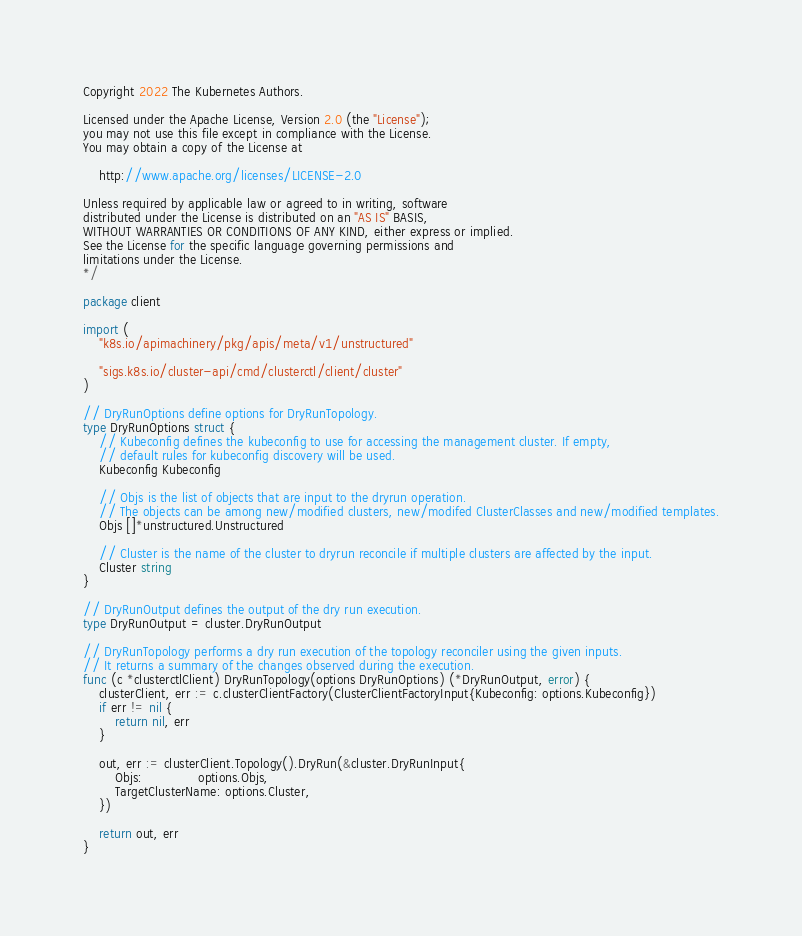<code> <loc_0><loc_0><loc_500><loc_500><_Go_>Copyright 2022 The Kubernetes Authors.

Licensed under the Apache License, Version 2.0 (the "License");
you may not use this file except in compliance with the License.
You may obtain a copy of the License at

    http://www.apache.org/licenses/LICENSE-2.0

Unless required by applicable law or agreed to in writing, software
distributed under the License is distributed on an "AS IS" BASIS,
WITHOUT WARRANTIES OR CONDITIONS OF ANY KIND, either express or implied.
See the License for the specific language governing permissions and
limitations under the License.
*/

package client

import (
	"k8s.io/apimachinery/pkg/apis/meta/v1/unstructured"

	"sigs.k8s.io/cluster-api/cmd/clusterctl/client/cluster"
)

// DryRunOptions define options for DryRunTopology.
type DryRunOptions struct {
	// Kubeconfig defines the kubeconfig to use for accessing the management cluster. If empty,
	// default rules for kubeconfig discovery will be used.
	Kubeconfig Kubeconfig

	// Objs is the list of objects that are input to the dryrun operation.
	// The objects can be among new/modified clusters, new/modifed ClusterClasses and new/modified templates.
	Objs []*unstructured.Unstructured

	// Cluster is the name of the cluster to dryrun reconcile if multiple clusters are affected by the input.
	Cluster string
}

// DryRunOutput defines the output of the dry run execution.
type DryRunOutput = cluster.DryRunOutput

// DryRunTopology performs a dry run execution of the topology reconciler using the given inputs.
// It returns a summary of the changes observed during the execution.
func (c *clusterctlClient) DryRunTopology(options DryRunOptions) (*DryRunOutput, error) {
	clusterClient, err := c.clusterClientFactory(ClusterClientFactoryInput{Kubeconfig: options.Kubeconfig})
	if err != nil {
		return nil, err
	}

	out, err := clusterClient.Topology().DryRun(&cluster.DryRunInput{
		Objs:              options.Objs,
		TargetClusterName: options.Cluster,
	})

	return out, err
}
</code> 